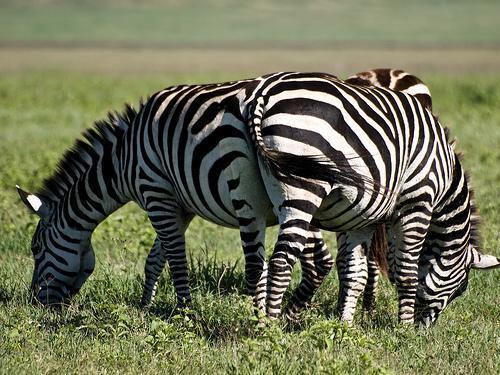How many zebras are there?
Give a very brief answer. 2. 